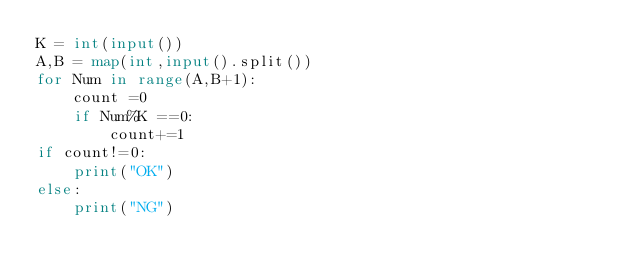<code> <loc_0><loc_0><loc_500><loc_500><_Python_>K = int(input())
A,B = map(int,input().split())
for Num in range(A,B+1):
    count =0
    if Num%K ==0:
        count+=1
if count!=0:
    print("OK")
else:
    print("NG")
</code> 